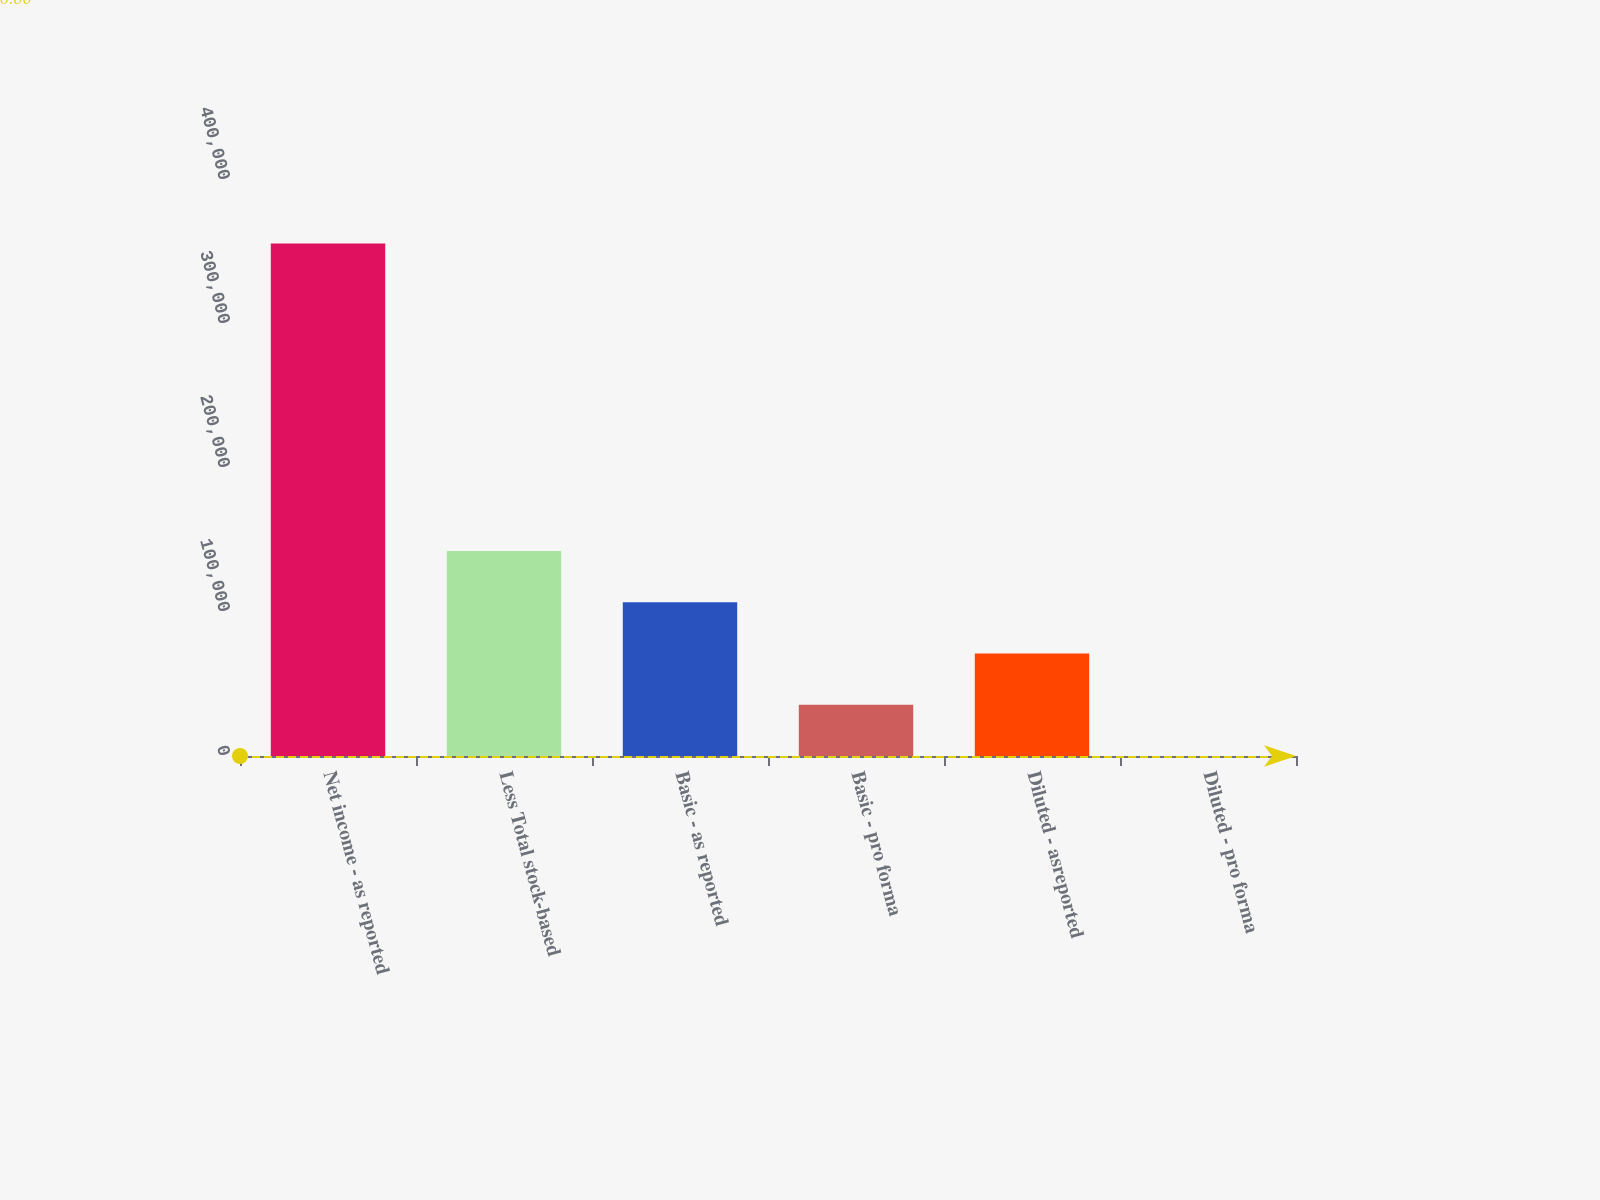Convert chart to OTSL. <chart><loc_0><loc_0><loc_500><loc_500><bar_chart><fcel>Net income - as reported<fcel>Less Total stock-based<fcel>Basic - as reported<fcel>Basic - pro forma<fcel>Diluted - asreported<fcel>Diluted - pro forma<nl><fcel>355961<fcel>142385<fcel>106789<fcel>35596.9<fcel>71192.9<fcel>0.86<nl></chart> 